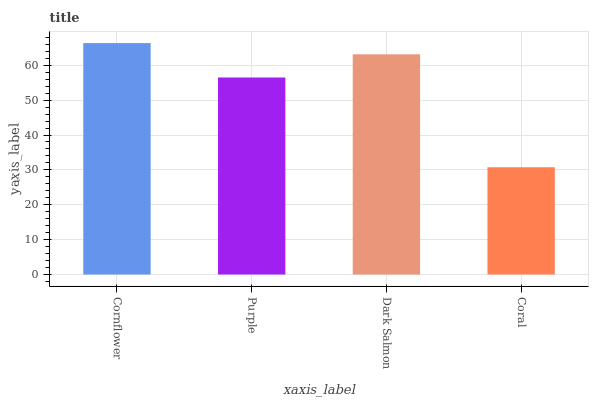Is Coral the minimum?
Answer yes or no. Yes. Is Cornflower the maximum?
Answer yes or no. Yes. Is Purple the minimum?
Answer yes or no. No. Is Purple the maximum?
Answer yes or no. No. Is Cornflower greater than Purple?
Answer yes or no. Yes. Is Purple less than Cornflower?
Answer yes or no. Yes. Is Purple greater than Cornflower?
Answer yes or no. No. Is Cornflower less than Purple?
Answer yes or no. No. Is Dark Salmon the high median?
Answer yes or no. Yes. Is Purple the low median?
Answer yes or no. Yes. Is Coral the high median?
Answer yes or no. No. Is Cornflower the low median?
Answer yes or no. No. 